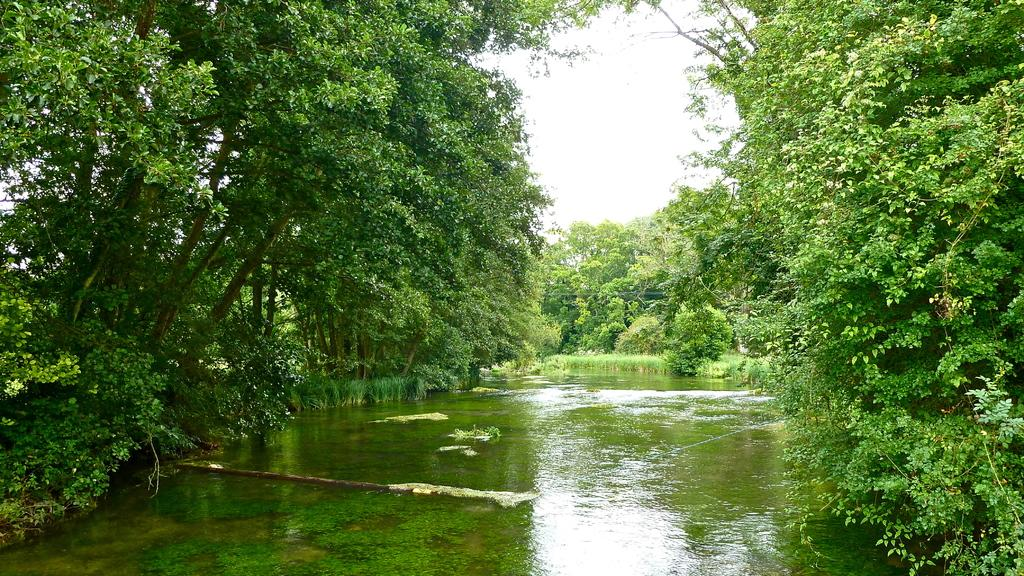What is the primary element visible in the image? There is water in the image. What can be seen in the background of the image? There are trees and the sky visible in the background of the image. What is the profit margin of the company depicted in the image? There is no company or profit margin mentioned in the image; it primarily features water with trees and the sky in the background. 